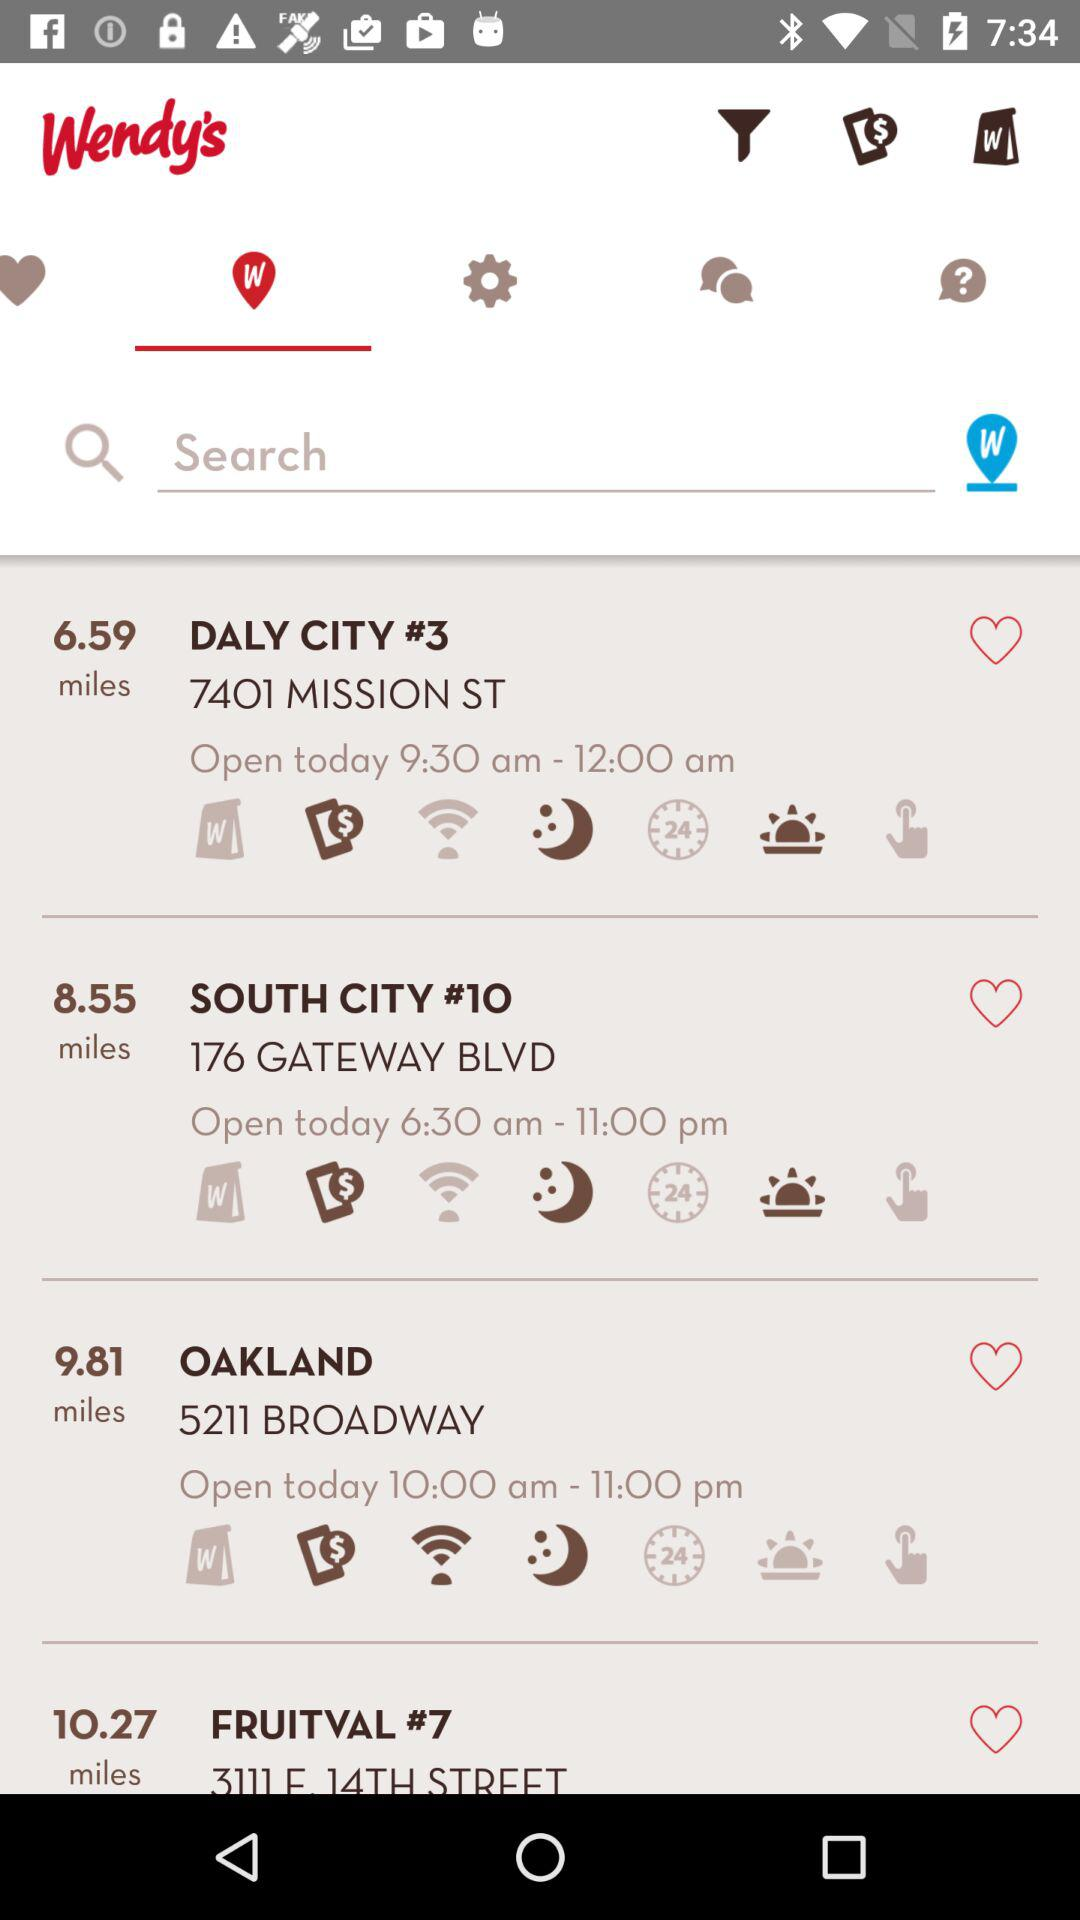What is the address of South City #10? The address is 176 Gateway Blvd. 